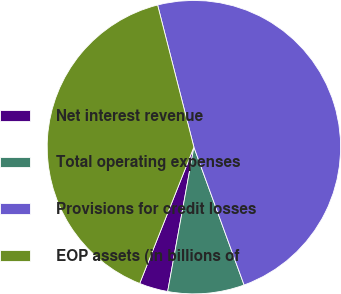<chart> <loc_0><loc_0><loc_500><loc_500><pie_chart><fcel>Net interest revenue<fcel>Total operating expenses<fcel>Provisions for credit losses<fcel>EOP assets (in billions of<nl><fcel>3.16%<fcel>8.42%<fcel>48.42%<fcel>40.0%<nl></chart> 